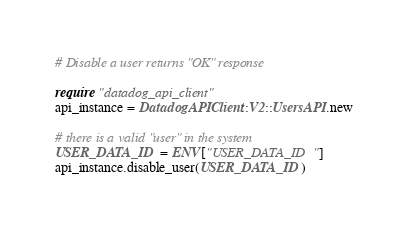<code> <loc_0><loc_0><loc_500><loc_500><_Ruby_># Disable a user returns "OK" response

require "datadog_api_client"
api_instance = DatadogAPIClient::V2::UsersAPI.new

# there is a valid "user" in the system
USER_DATA_ID = ENV["USER_DATA_ID"]
api_instance.disable_user(USER_DATA_ID)
</code> 